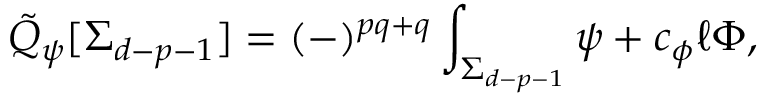<formula> <loc_0><loc_0><loc_500><loc_500>\tilde { Q } _ { \psi } [ \Sigma _ { d - p - 1 } ] = ( - ) ^ { p q + q } \int _ { \Sigma _ { d - p - 1 } } \psi + c _ { \phi } \ell \Phi ,</formula> 